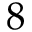Convert formula to latex. <formula><loc_0><loc_0><loc_500><loc_500>8</formula> 